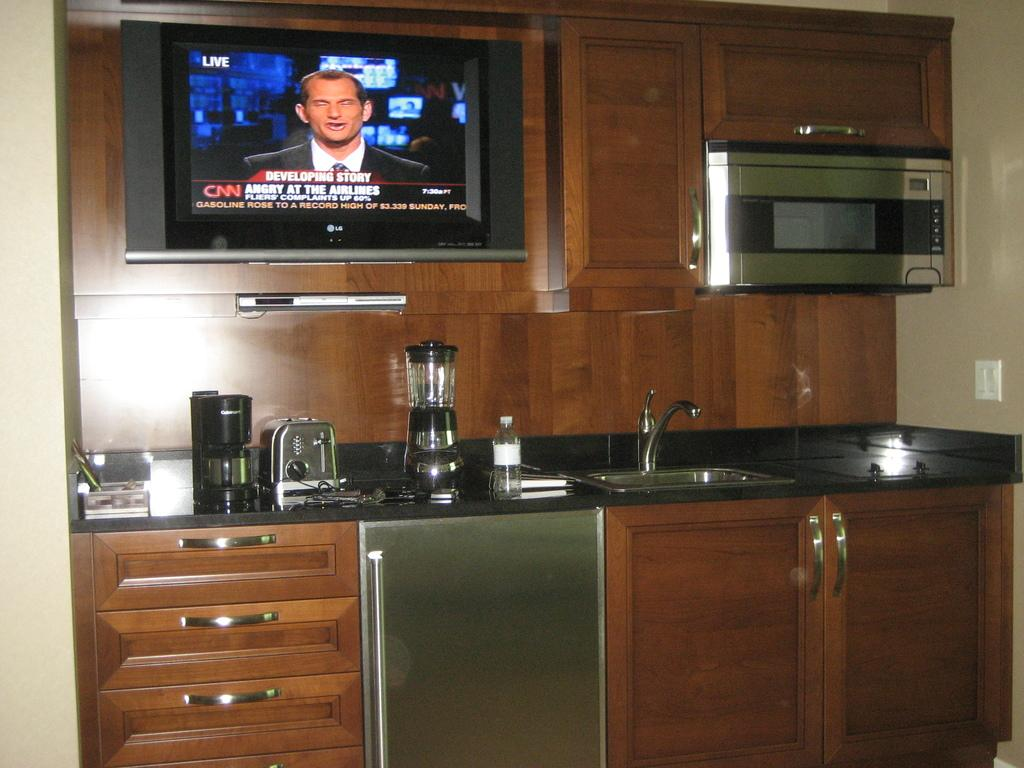<image>
Render a clear and concise summary of the photo. a tv screen in a kitchen that has CNN on it 